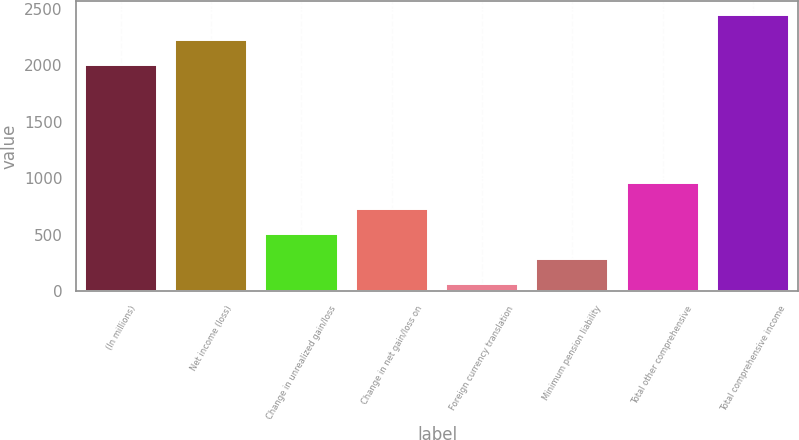Convert chart. <chart><loc_0><loc_0><loc_500><loc_500><bar_chart><fcel>(In millions)<fcel>Net income (loss)<fcel>Change in unrealized gain/loss<fcel>Change in net gain/loss on<fcel>Foreign currency translation<fcel>Minimum pension liability<fcel>Total other comprehensive<fcel>Total comprehensive income<nl><fcel>2004<fcel>2227.5<fcel>506<fcel>729.5<fcel>59<fcel>282.5<fcel>953<fcel>2451<nl></chart> 